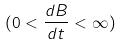Convert formula to latex. <formula><loc_0><loc_0><loc_500><loc_500>( 0 < \frac { d B } { d t } < \infty )</formula> 